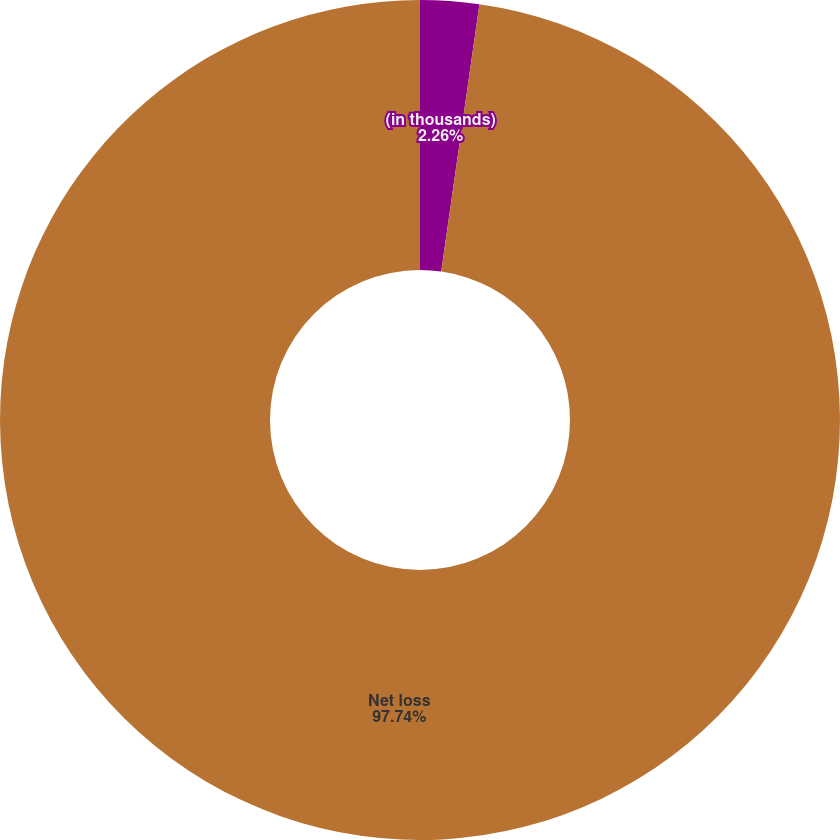Convert chart. <chart><loc_0><loc_0><loc_500><loc_500><pie_chart><fcel>(in thousands)<fcel>Net loss<nl><fcel>2.26%<fcel>97.74%<nl></chart> 